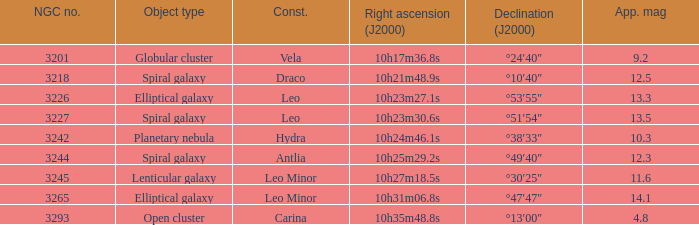What is the total of Apparent magnitudes for an NGC number larger than 3293? None. 